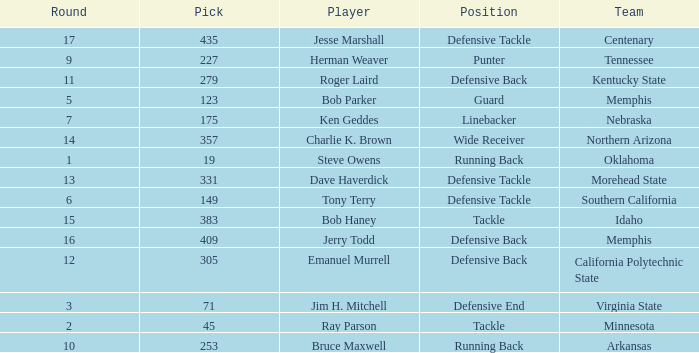What is the lowest pick of the defensive tackle player dave haverdick? 331.0. Give me the full table as a dictionary. {'header': ['Round', 'Pick', 'Player', 'Position', 'Team'], 'rows': [['17', '435', 'Jesse Marshall', 'Defensive Tackle', 'Centenary'], ['9', '227', 'Herman Weaver', 'Punter', 'Tennessee'], ['11', '279', 'Roger Laird', 'Defensive Back', 'Kentucky State'], ['5', '123', 'Bob Parker', 'Guard', 'Memphis'], ['7', '175', 'Ken Geddes', 'Linebacker', 'Nebraska'], ['14', '357', 'Charlie K. Brown', 'Wide Receiver', 'Northern Arizona'], ['1', '19', 'Steve Owens', 'Running Back', 'Oklahoma'], ['13', '331', 'Dave Haverdick', 'Defensive Tackle', 'Morehead State'], ['6', '149', 'Tony Terry', 'Defensive Tackle', 'Southern California'], ['15', '383', 'Bob Haney', 'Tackle', 'Idaho'], ['16', '409', 'Jerry Todd', 'Defensive Back', 'Memphis'], ['12', '305', 'Emanuel Murrell', 'Defensive Back', 'California Polytechnic State'], ['3', '71', 'Jim H. Mitchell', 'Defensive End', 'Virginia State'], ['2', '45', 'Ray Parson', 'Tackle', 'Minnesota'], ['10', '253', 'Bruce Maxwell', 'Running Back', 'Arkansas']]} 